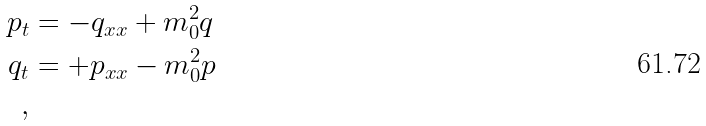<formula> <loc_0><loc_0><loc_500><loc_500>p _ { t } & = - q _ { x x } + m _ { 0 } ^ { 2 } q \\ q _ { t } & = + p _ { x x } - m _ { 0 } ^ { 2 } p \\ ,</formula> 